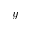<formula> <loc_0><loc_0><loc_500><loc_500>y</formula> 